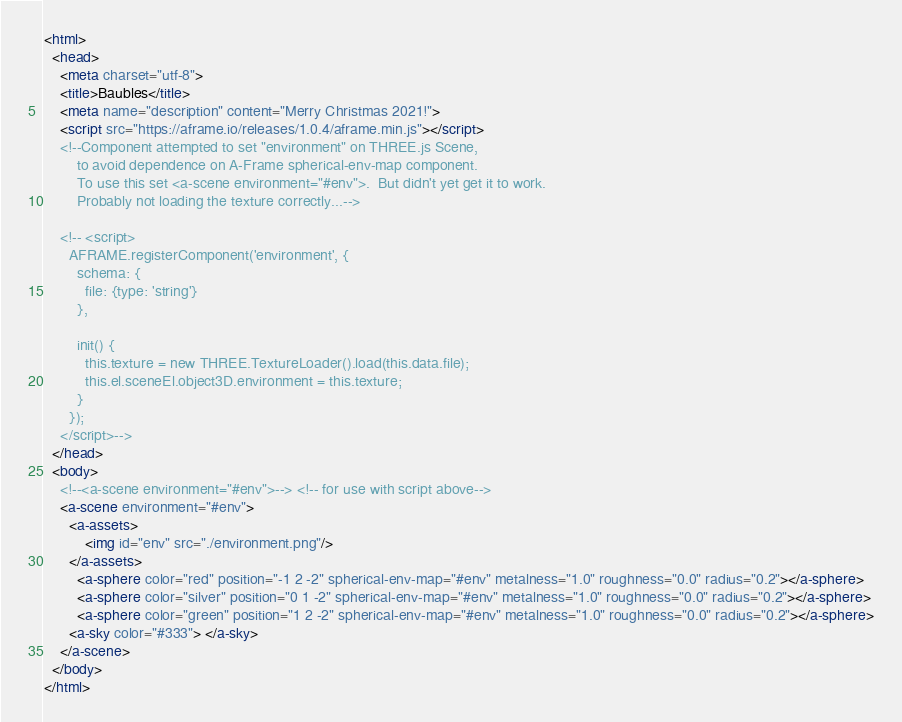Convert code to text. <code><loc_0><loc_0><loc_500><loc_500><_HTML_><html>
  <head>
    <meta charset="utf-8">
    <title>Baubles</title>
    <meta name="description" content="Merry Christmas 2021!">
    <script src="https://aframe.io/releases/1.0.4/aframe.min.js"></script>
    <!--Component attempted to set "environment" on THREE.js Scene,
        to avoid dependence on A-Frame spherical-env-map component.
        To use this set <a-scene environment="#env">.  But didn't yet get it to work.
        Probably not loading the texture correctly...-->

    <!-- <script>
      AFRAME.registerComponent('environment', {
        schema: {
          file: {type: 'string'}
        },

        init() {
          this.texture = new THREE.TextureLoader().load(this.data.file);
          this.el.sceneEl.object3D.environment = this.texture;
        }
      });
    </script>-->
  </head>
  <body>
    <!--<a-scene environment="#env">--> <!-- for use with script above-->
    <a-scene environment="#env">
      <a-assets>
          <img id="env" src="./environment.png"/>
      </a-assets>
        <a-sphere color="red" position="-1 2 -2" spherical-env-map="#env" metalness="1.0" roughness="0.0" radius="0.2"></a-sphere>
        <a-sphere color="silver" position="0 1 -2" spherical-env-map="#env" metalness="1.0" roughness="0.0" radius="0.2"></a-sphere>
        <a-sphere color="green" position="1 2 -2" spherical-env-map="#env" metalness="1.0" roughness="0.0" radius="0.2"></a-sphere>
      <a-sky color="#333"> </a-sky>
    </a-scene>
  </body>
</html>
</code> 